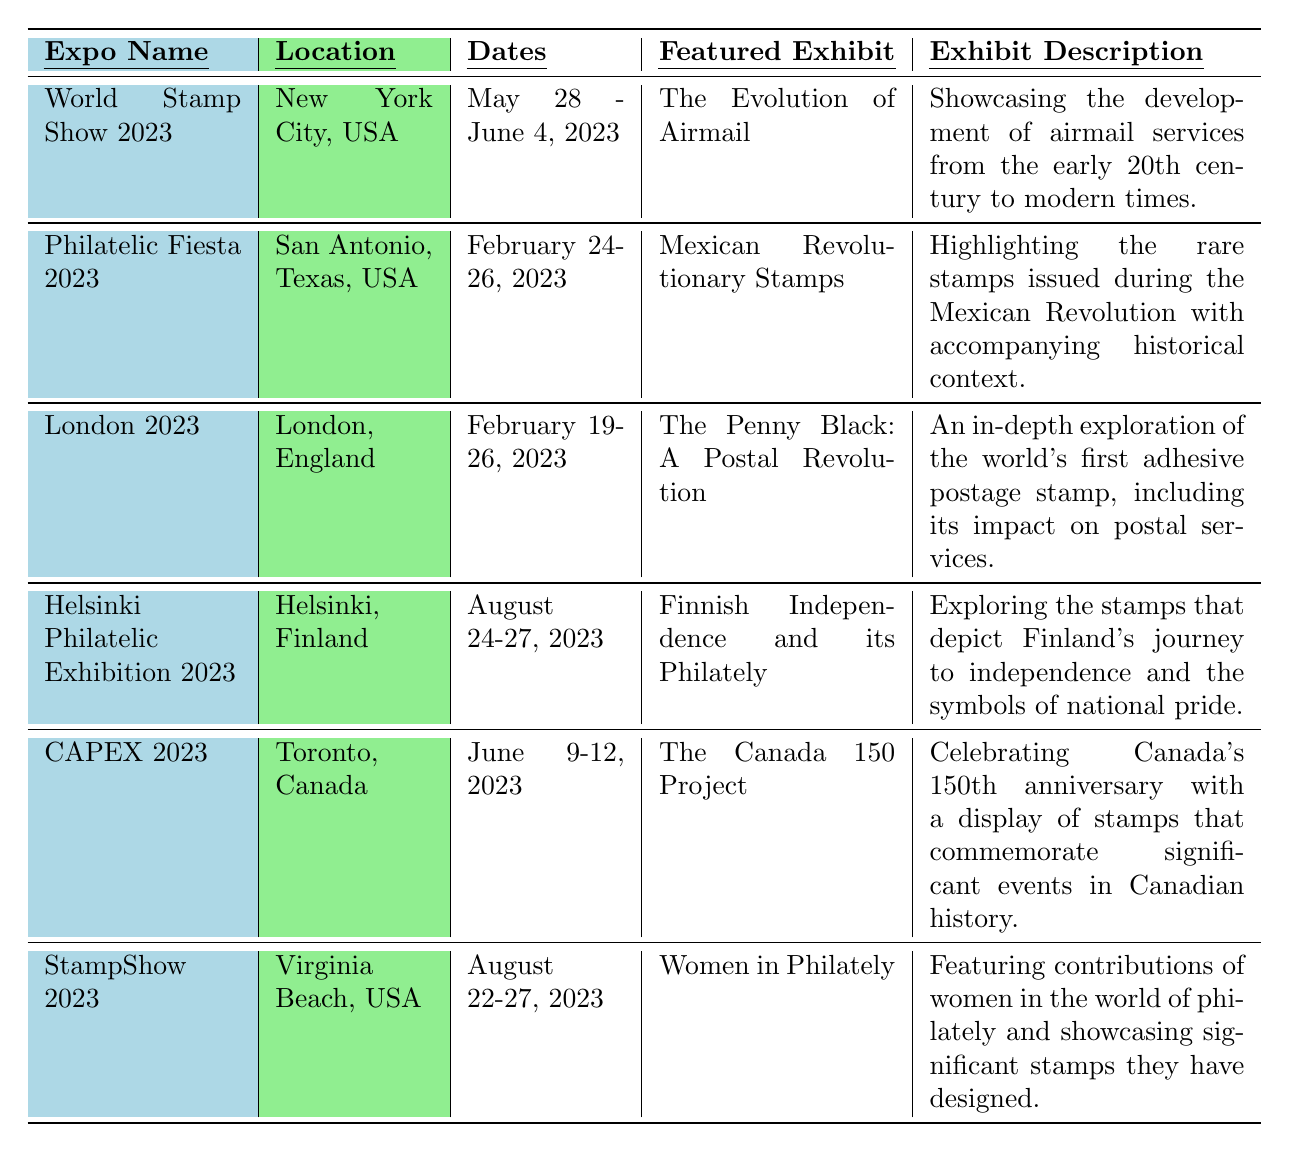What is the location of the World Stamp Show 2023? The table lists the event and its corresponding location. By finding "World Stamp Show 2023" in the Expo Name column, we look across to the Location column and find "New York City, USA."
Answer: New York City, USA Which featured exhibit is related to women's contributions in philately? "Women in Philately" is explicitly listed as the featured exhibit under "StampShow 2023." We can confirm this by checking the respective column.
Answer: Women in Philately How many days did the Philatelic Fiesta 2023 last? The dates for the Philatelic Fiesta 2023 are listed as "February 24-26, 2023," which indicates it lasted from February 24 to February 26, totaling 3 days when counting the start and end dates.
Answer: 3 days Which expo took place in June 2023? By examining the Dates column for June 2023, we find two events: "World Stamp Show 2023" from May 28 - June 4 and "CAPEX 2023" from June 9-12. Both are in June 2023.
Answer: World Stamp Show 2023 and CAPEX 2023 What is the main theme of the exhibit at London 2023? The featured exhibit for London 2023 is "The Penny Black: A Postal Revolution," as shown in the Featured Exhibit column. This can be cross-referenced with its description in the Exhibit Description column to understand the theme.
Answer: The world's first adhesive postage stamp Which exhibit focuses on a specific national event related to Finland? The "Finnish Independence and its Philately" exhibit at the Helsinki Philatelic Exhibition 2023 pertains to Finland's independence journey, found by checking the Featured Exhibit column for that expo.
Answer: Finnish Independence and its Philately How many total expos were held in the USA in 2023? There are three events related to the USA listed: "World Stamp Show 2023," "Philatelic Fiesta 2023," and "StampShow 2023." We simply count these occurrences in the Expo Name column.
Answer: 3 expos Is the exhibit "The Canada 150 Project" related to a milestone anniversary? Yes, the exhibit's title suggests it commemorates Canada’s 150th anniversary, and it describes significant events in Canadian history, confirming it aligns with a milestone celebration.
Answer: Yes What is the chronological order of the expos from February to August? By checking the Dates column, we can see the sequence: London 2023 in February, followed by Philatelic Fiesta 2023 also in February, then World Stamp Show 2023 in late May to early June, CAPEX 2023 in June, and finally StampShow 2023 and Helsinki Philatelic Exhibition in August. Listing them gives their chronological order.
Answer: London 2023, Philatelic Fiesta 2023, World Stamp Show 2023, CAPEX 2023, StampShow 2023, Helsinki Philatelic Exhibition 2023 